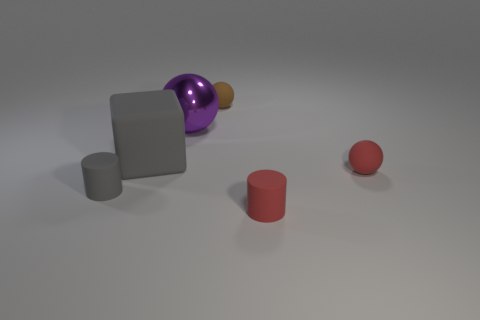Subtract all matte balls. How many balls are left? 1 Subtract 3 balls. How many balls are left? 0 Subtract all red spheres. How many spheres are left? 2 Add 1 large purple balls. How many objects exist? 7 Subtract all cylinders. How many objects are left? 4 Subtract all gray cylinders. How many purple spheres are left? 1 Subtract 1 brown spheres. How many objects are left? 5 Subtract all cyan cylinders. Subtract all gray cubes. How many cylinders are left? 2 Subtract all large gray objects. Subtract all tiny cylinders. How many objects are left? 3 Add 4 gray rubber cylinders. How many gray rubber cylinders are left? 5 